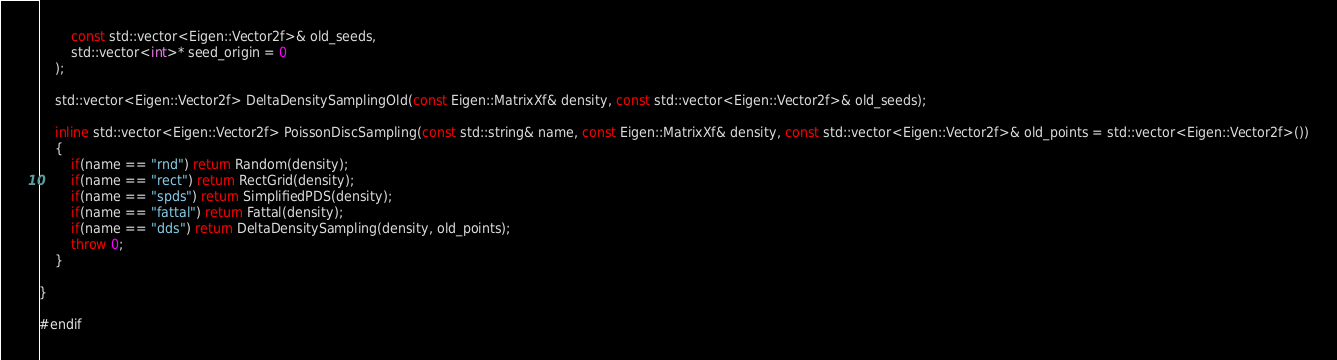<code> <loc_0><loc_0><loc_500><loc_500><_C++_>		const std::vector<Eigen::Vector2f>& old_seeds,
		std::vector<int>* seed_origin = 0
	);

	std::vector<Eigen::Vector2f> DeltaDensitySamplingOld(const Eigen::MatrixXf& density, const std::vector<Eigen::Vector2f>& old_seeds);

	inline std::vector<Eigen::Vector2f> PoissonDiscSampling(const std::string& name, const Eigen::MatrixXf& density, const std::vector<Eigen::Vector2f>& old_points = std::vector<Eigen::Vector2f>())
	{
		if(name == "rnd") return Random(density);
		if(name == "rect") return RectGrid(density);
		if(name == "spds") return SimplifiedPDS(density);
		if(name == "fattal") return Fattal(density);
		if(name == "dds") return DeltaDensitySampling(density, old_points);
		throw 0;
	}

}

#endif
</code> 